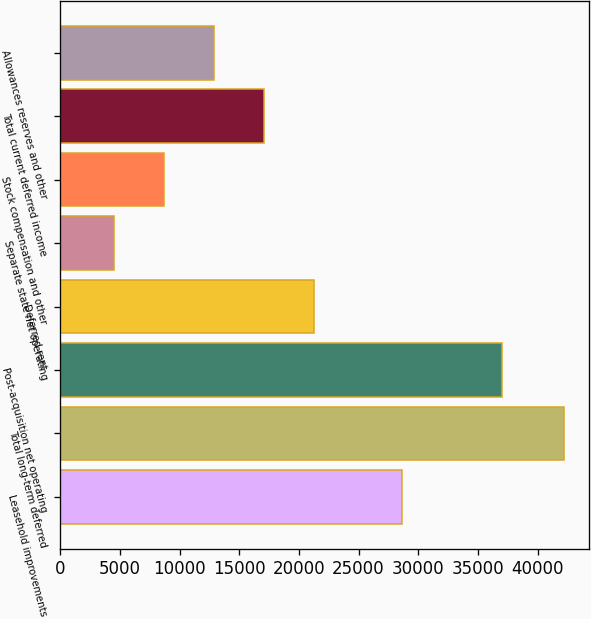Convert chart to OTSL. <chart><loc_0><loc_0><loc_500><loc_500><bar_chart><fcel>Leasehold improvements<fcel>Total long-term deferred<fcel>Post-acquisition net operating<fcel>Deferred rent<fcel>Separate state net operating<fcel>Stock compensation and other<fcel>Total current deferred income<fcel>Allowances reserves and other<nl><fcel>28627<fcel>42213<fcel>37010.4<fcel>21254.5<fcel>4487.7<fcel>8679.4<fcel>17062.8<fcel>12871.1<nl></chart> 